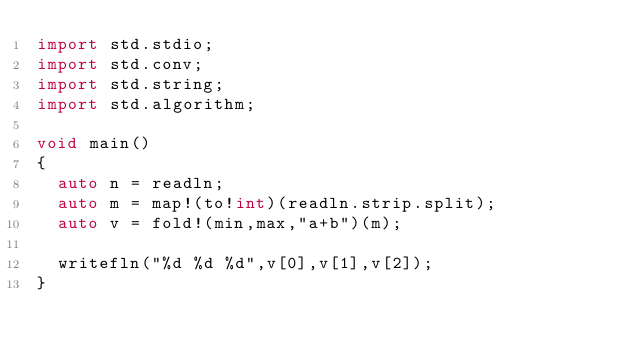Convert code to text. <code><loc_0><loc_0><loc_500><loc_500><_D_>import std.stdio;
import std.conv;
import std.string;
import std.algorithm;

void main()
{
  auto n = readln;
  auto m = map!(to!int)(readln.strip.split);
  auto v = fold!(min,max,"a+b")(m);

  writefln("%d %d %d",v[0],v[1],v[2]);
}</code> 